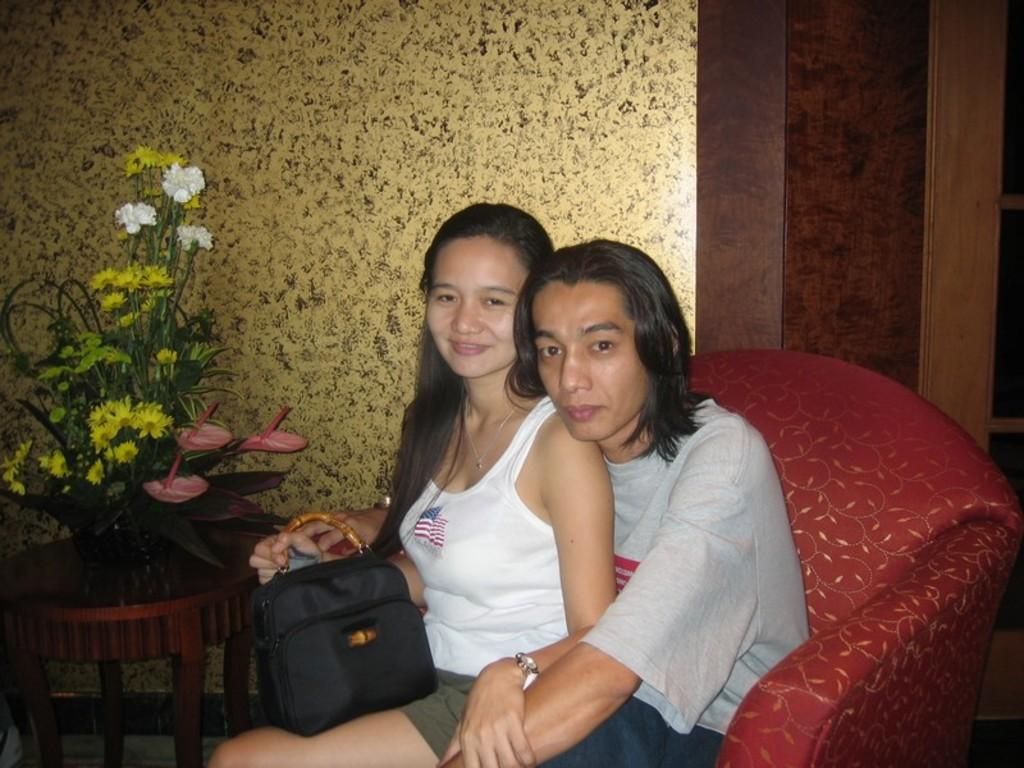How many people are sitting in the image? There are two people sitting in the image. What are the people sitting on? The people are sitting on chairs in the image. What can be seen on the table in the image? There is a flower pot on a table in the image. What is visible in the background of the image? There is a wall in the background of the image. What grade did the person sitting on the sofa receive on their test? There is no sofa present in the image, and no test or grades are mentioned. 